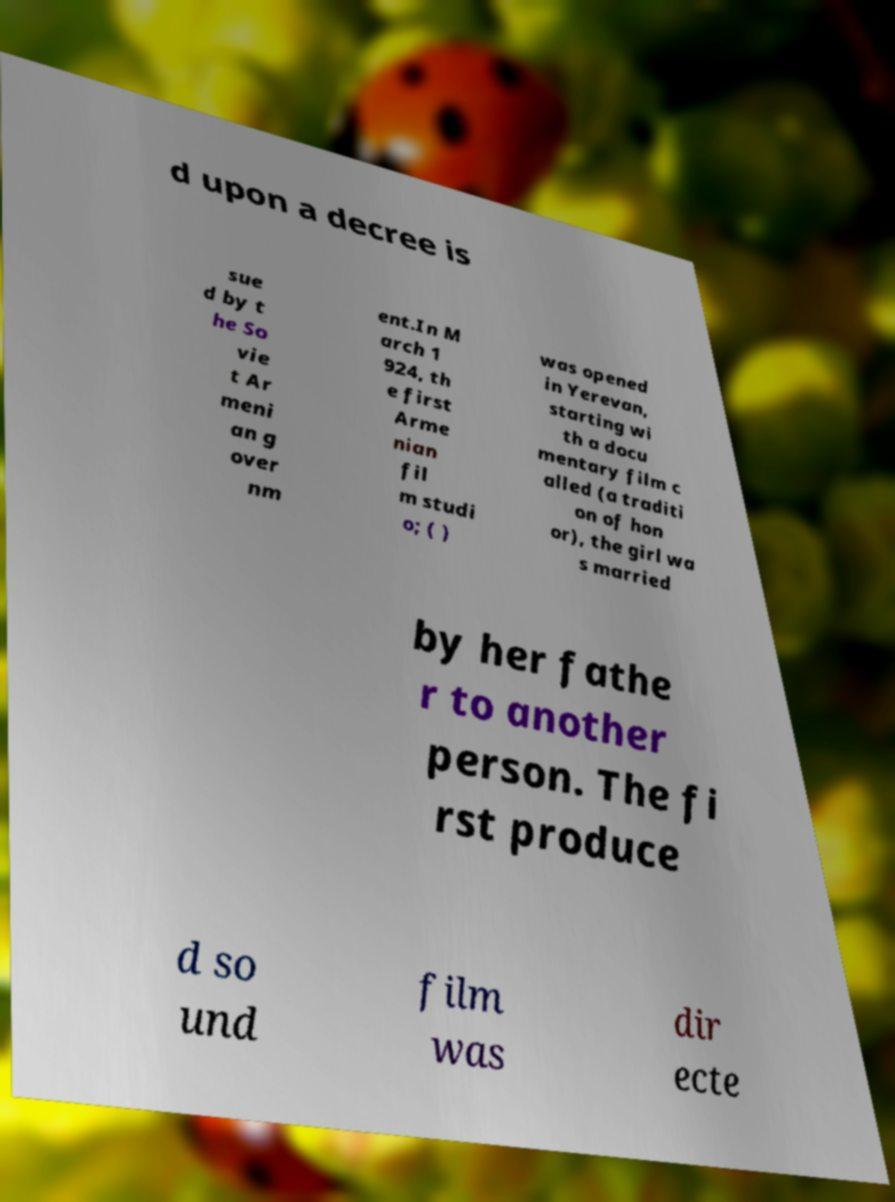Could you assist in decoding the text presented in this image and type it out clearly? d upon a decree is sue d by t he So vie t Ar meni an g over nm ent.In M arch 1 924, th e first Arme nian fil m studi o; ( ) was opened in Yerevan, starting wi th a docu mentary film c alled (a traditi on of hon or), the girl wa s married by her fathe r to another person. The fi rst produce d so und film was dir ecte 